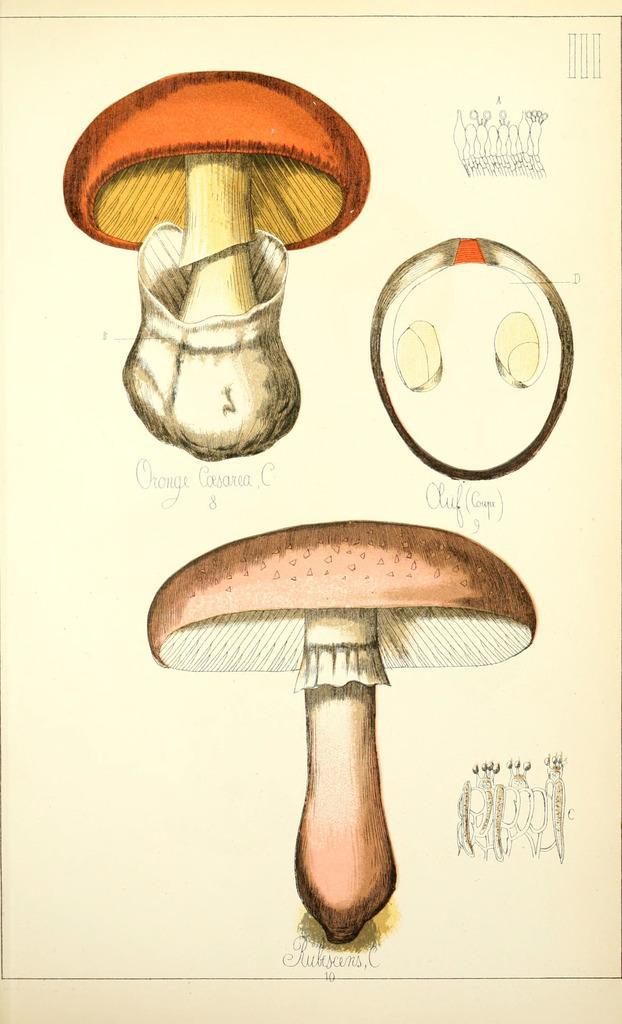In one or two sentences, can you explain what this image depicts? In this image I can see three mushrooms and a group of radish and a text. The background is light cream in color. This image is taken may be during a day. 